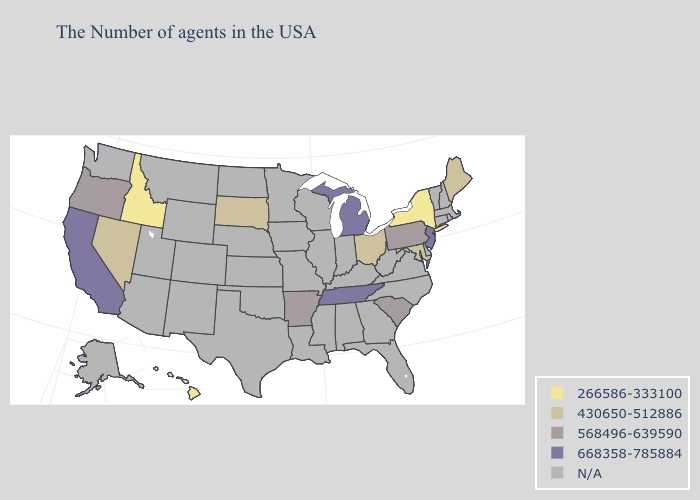Which states have the lowest value in the West?
Keep it brief. Idaho, Hawaii. Name the states that have a value in the range 568496-639590?
Quick response, please. Pennsylvania, South Carolina, Arkansas, Oregon. What is the lowest value in the Northeast?
Be succinct. 266586-333100. Which states have the lowest value in the MidWest?
Be succinct. Ohio, South Dakota. Name the states that have a value in the range 568496-639590?
Answer briefly. Pennsylvania, South Carolina, Arkansas, Oregon. What is the lowest value in states that border Nebraska?
Quick response, please. 430650-512886. Is the legend a continuous bar?
Give a very brief answer. No. How many symbols are there in the legend?
Be succinct. 5. Which states have the lowest value in the West?
Write a very short answer. Idaho, Hawaii. What is the value of Texas?
Quick response, please. N/A. What is the highest value in the Northeast ?
Be succinct. 668358-785884. Name the states that have a value in the range 266586-333100?
Be succinct. New York, Idaho, Hawaii. 